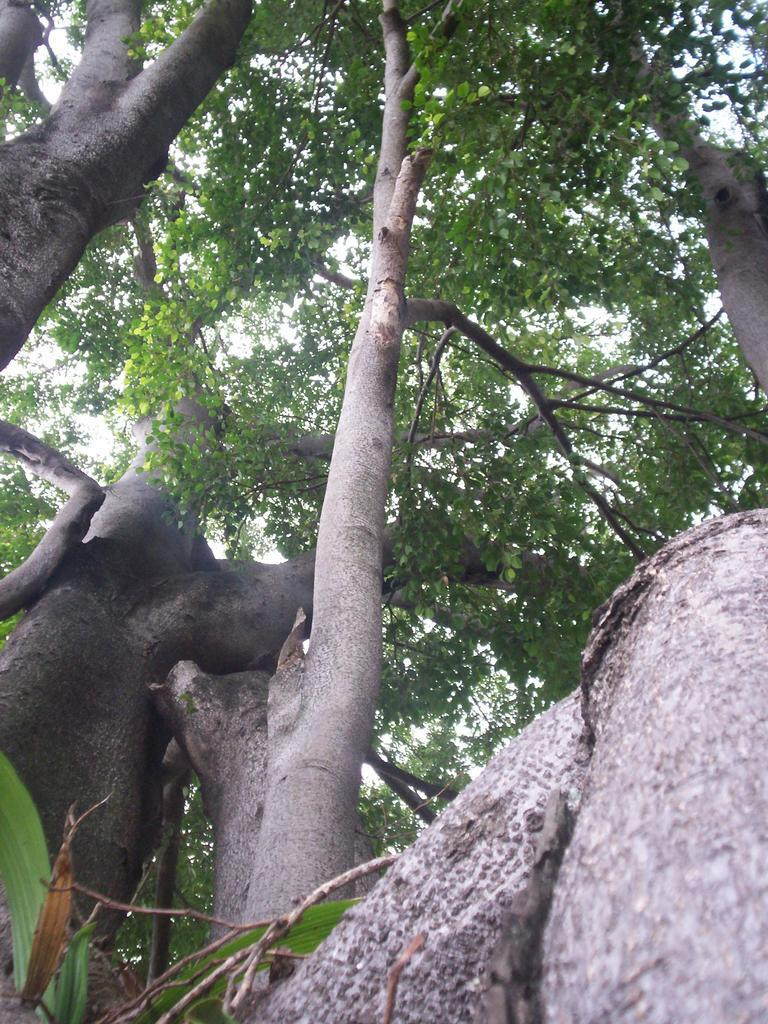What type of vegetation can be seen in the image? There are trees in the image. How many trees are visible in the image? The number of trees cannot be determined from the provided facts. What can be inferred about the environment based on the presence of trees? The presence of trees suggests that the image may be taken in a natural or outdoor setting. How long does it take for the minute hand to move around the clock in the image? There is no clock present in the image, so it is not possible to answer this question. 